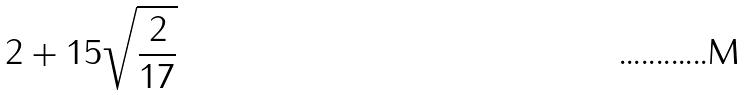Convert formula to latex. <formula><loc_0><loc_0><loc_500><loc_500>2 + 1 5 \sqrt { \frac { 2 } { 1 7 } }</formula> 